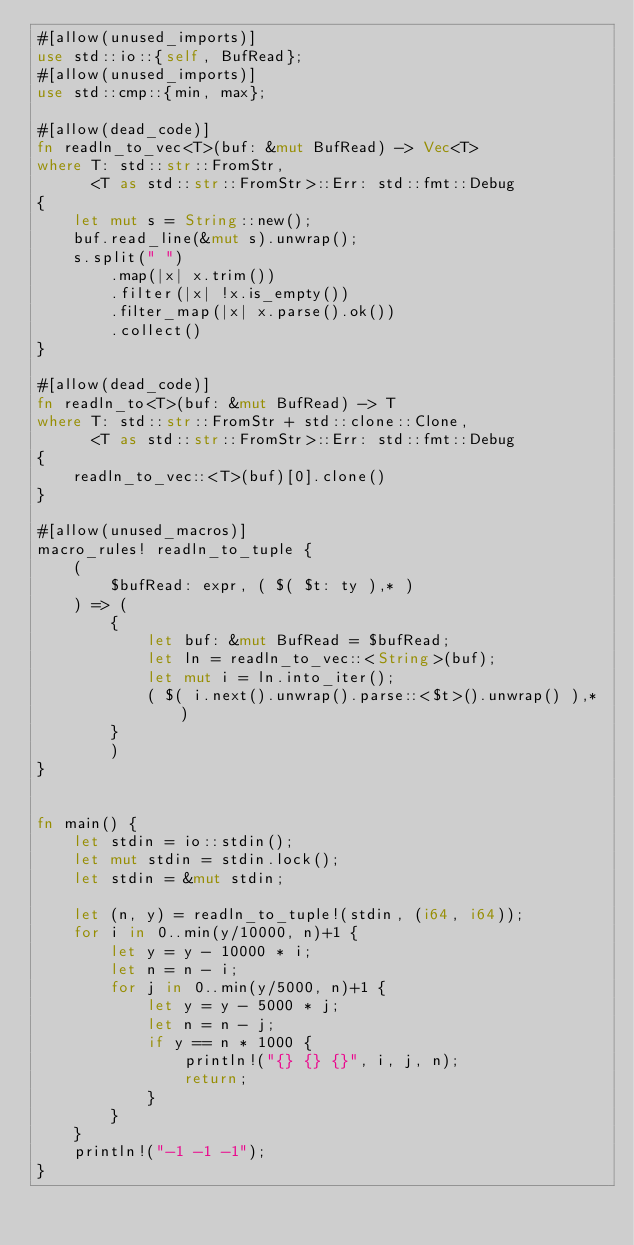Convert code to text. <code><loc_0><loc_0><loc_500><loc_500><_Rust_>#[allow(unused_imports)]
use std::io::{self, BufRead};
#[allow(unused_imports)]
use std::cmp::{min, max};

#[allow(dead_code)]
fn readln_to_vec<T>(buf: &mut BufRead) -> Vec<T> 
where T: std::str::FromStr,
      <T as std::str::FromStr>::Err: std::fmt::Debug
{
    let mut s = String::new();
    buf.read_line(&mut s).unwrap();
    s.split(" ")
        .map(|x| x.trim())
        .filter(|x| !x.is_empty())
        .filter_map(|x| x.parse().ok())
        .collect()
}

#[allow(dead_code)]
fn readln_to<T>(buf: &mut BufRead) -> T
where T: std::str::FromStr + std::clone::Clone,
      <T as std::str::FromStr>::Err: std::fmt::Debug
{
    readln_to_vec::<T>(buf)[0].clone()
}

#[allow(unused_macros)]
macro_rules! readln_to_tuple {
    (
        $bufRead: expr, ( $( $t: ty ),* )
    ) => (
        {
            let buf: &mut BufRead = $bufRead;
            let ln = readln_to_vec::<String>(buf);
            let mut i = ln.into_iter();
            ( $( i.next().unwrap().parse::<$t>().unwrap() ),* )
        }
        )
}


fn main() {
    let stdin = io::stdin();
    let mut stdin = stdin.lock();
    let stdin = &mut stdin;

    let (n, y) = readln_to_tuple!(stdin, (i64, i64));
    for i in 0..min(y/10000, n)+1 {
        let y = y - 10000 * i;
        let n = n - i;
        for j in 0..min(y/5000, n)+1 {
            let y = y - 5000 * j;
            let n = n - j;
            if y == n * 1000 {
                println!("{} {} {}", i, j, n);
                return;
            }
        }
    }
    println!("-1 -1 -1");
}

</code> 